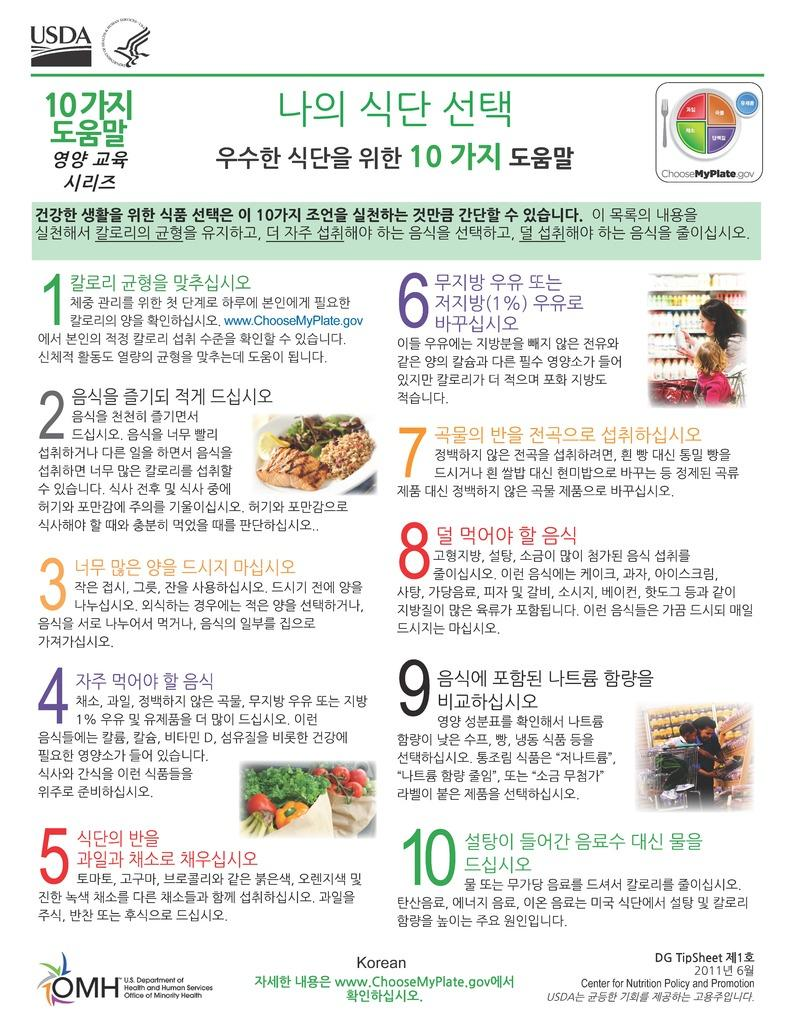What type of medium is the image likely to be? The image appears to be a printed, possibly from a magazine. What can be found in the image besides the visual elements? There is text in the image. What type of food items are depicted in the image? There are vegetables and fruits in the image. What are the bottles stored in? There are bottles in racks in the image. How many people are present in the image? There are three persons in the image. How many frogs are sitting on the toes of the person in the image? There are no frogs or toes visible in the image. What type of stem is holding up the fruits in the image? There is no stem present in the image; the fruits are placed on a surface. 